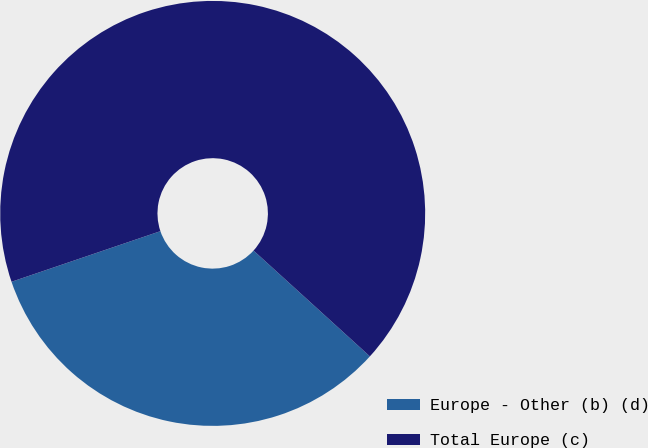Convert chart. <chart><loc_0><loc_0><loc_500><loc_500><pie_chart><fcel>Europe - Other (b) (d)<fcel>Total Europe (c)<nl><fcel>33.04%<fcel>66.96%<nl></chart> 